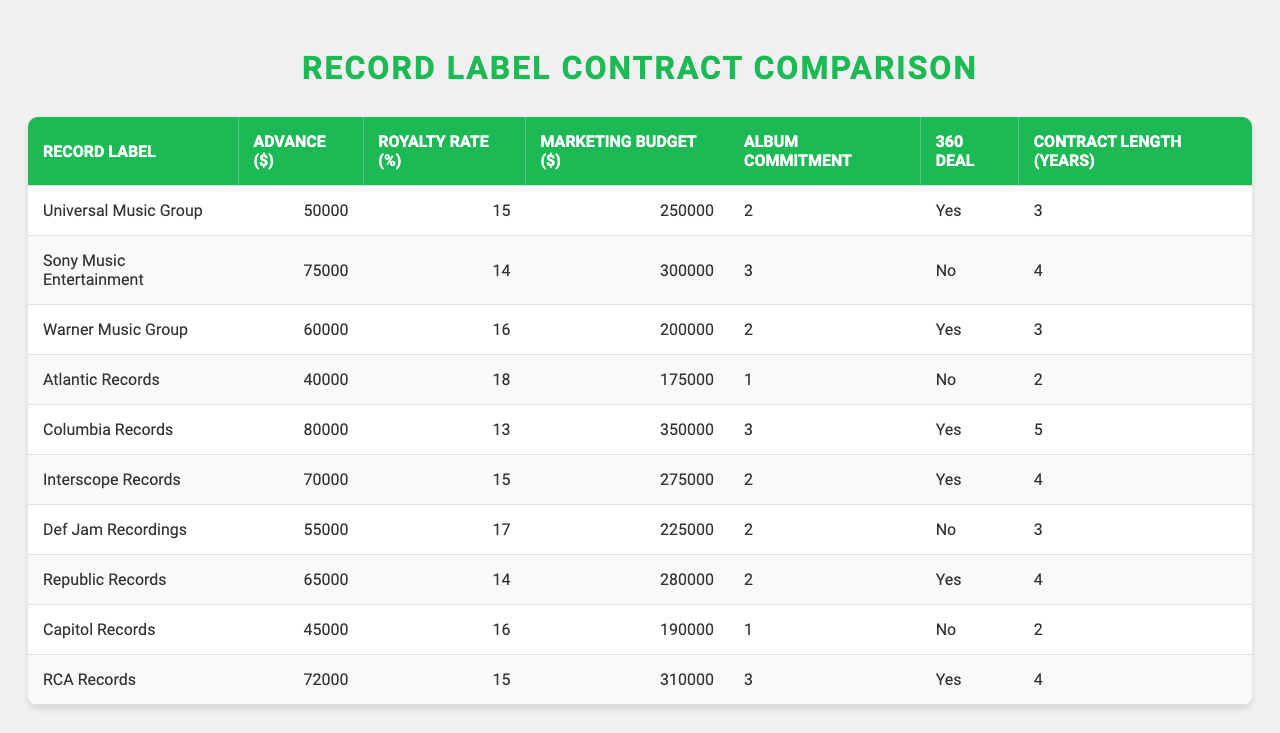What is the highest advance amount offered among the record labels? Reviewing the advance amounts listed for each label, the highest figure is $80,000 from Columbia Records.
Answer: $80,000 Which record label has the shortest contract length? The shortest contract length in the table is 1 year, offered by both Atlantic Records and Capitol Records.
Answer: 1 year What is the average royalty rate for all the record labels? To find the average, sum the royalty rates (15 + 14 + 16 + 18 + 13 + 15 + 17 + 14 + 16 + 15) which equals  151. Then divide by the number of labels (10) to get 151/10 = 15.1%.
Answer: 15.1% Does Universal Music Group offer a 360 deal? According to the table, Universal Music Group is marked as "Yes" for having a 360 deal.
Answer: Yes Which record label has the highest marketing budget along with the lowest album commitment? Review the labels for those with the lowest album commitment of 1 year, which are Atlantic Records and Capitol Records, with marketing budgets of $175,000 and $190,000, respectively. Capitol Records offers the highest marketing budget at $190,000 with a 1-year commitment.
Answer: Capitol Records How many record labels do not offer a 360 deal? By inspecting the "360 Deal" column, three labels are marked as "No": Sony Music Entertainment, Atlantic Records, and Def Jam Recordings.
Answer: 3 What is the total advance amount from all record labels? Adding all advance amounts together results in: 50000 + 75000 + 60000 + 40000 + 80000 + 70000 + 55000 + 65000 + 45000 + 72000 =  425000.
Answer: 425000 Which record label has the best royalty rate and how much is it? The label with the best (highest) royalty rate is Atlantic Records with a rate of 18%.
Answer: Atlantic Records, 18% How many record labels have a marketing budget above $250,000? Reviewing the "Marketing Budget" values, four labels exceed $250,000: Sony Music Entertainment ($300,000), Columbia Records ($350,000), RCA Records ($310,000), and Interscope Records ($275,000).
Answer: 4 What is the difference between the highest and lowest advance amounts? The highest advance is $80,000 (Columbia Records) and the lowest is $40,000 (Atlantic Records), so the difference is 80,000 - 40,000 = 40,000.
Answer: $40,000 